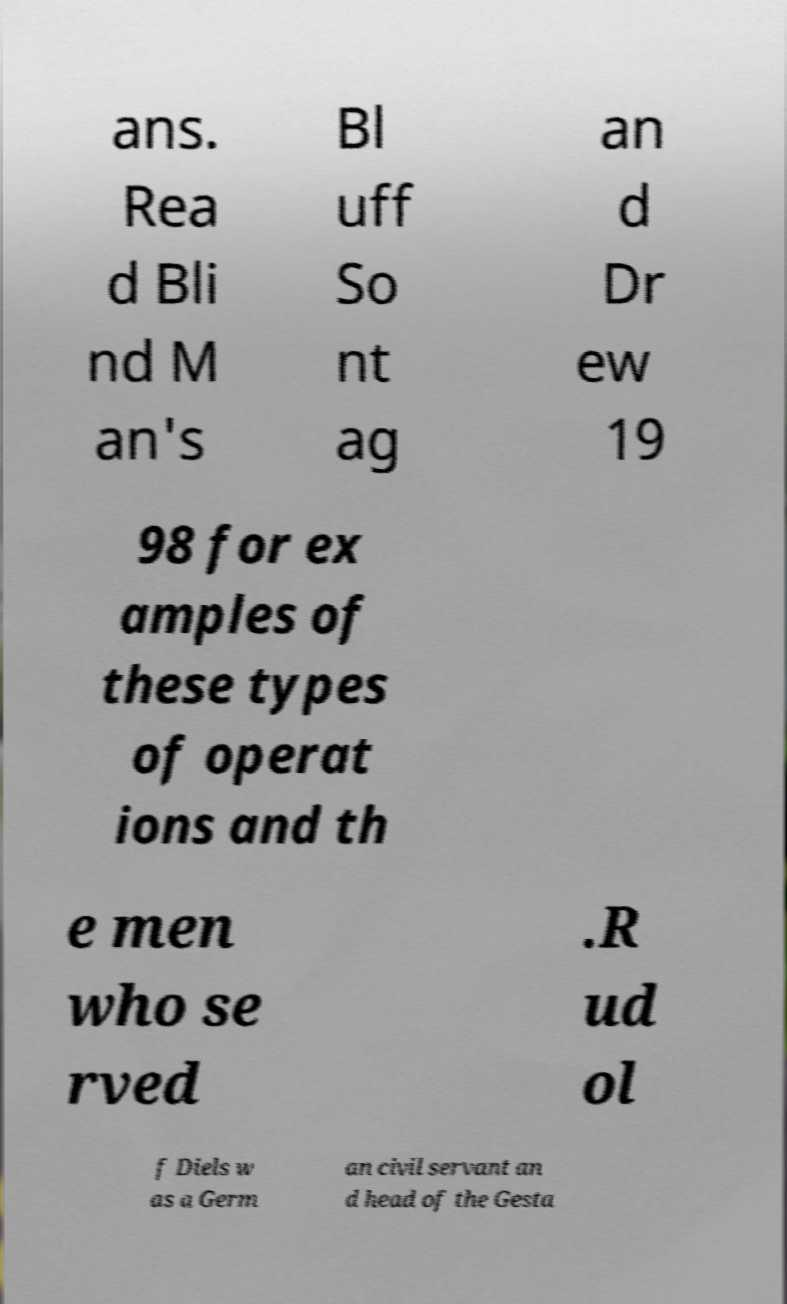Can you read and provide the text displayed in the image?This photo seems to have some interesting text. Can you extract and type it out for me? ans. Rea d Bli nd M an's Bl uff So nt ag an d Dr ew 19 98 for ex amples of these types of operat ions and th e men who se rved .R ud ol f Diels w as a Germ an civil servant an d head of the Gesta 